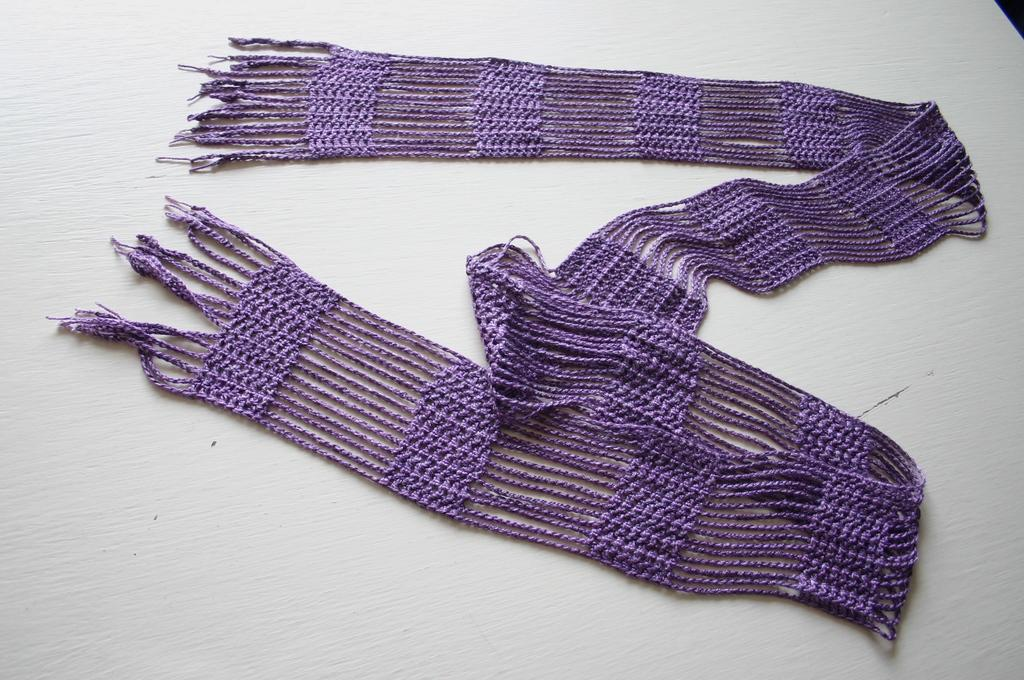What color is the scarf in the image? The scarf in the image is purple. Where is the scarf located in the image? The scarf is on a table in the image. What type of police action is taking place in the image? There is no police action present in the image; it only features a purple scarf on a table. 